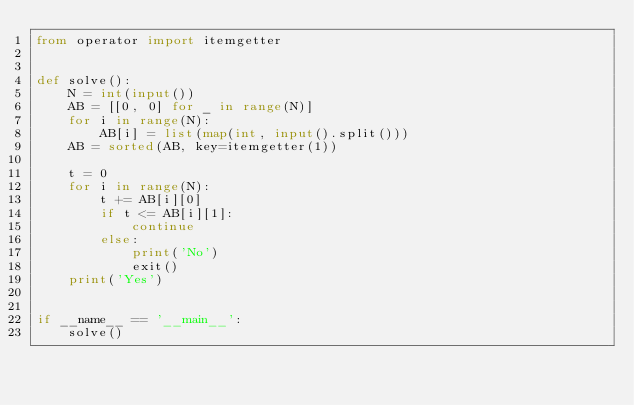Convert code to text. <code><loc_0><loc_0><loc_500><loc_500><_Python_>from operator import itemgetter


def solve():
    N = int(input())
    AB = [[0, 0] for _ in range(N)]
    for i in range(N):
        AB[i] = list(map(int, input().split()))
    AB = sorted(AB, key=itemgetter(1))

    t = 0
    for i in range(N):
        t += AB[i][0]
        if t <= AB[i][1]:
            continue
        else:
            print('No')
            exit()
    print('Yes')


if __name__ == '__main__':
    solve()</code> 